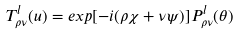<formula> <loc_0><loc_0><loc_500><loc_500>T _ { \rho \nu } ^ { l } ( u ) = e x p [ - i ( \rho \chi + \nu \psi ) ] P _ { \rho \nu } ^ { l } ( \theta )</formula> 